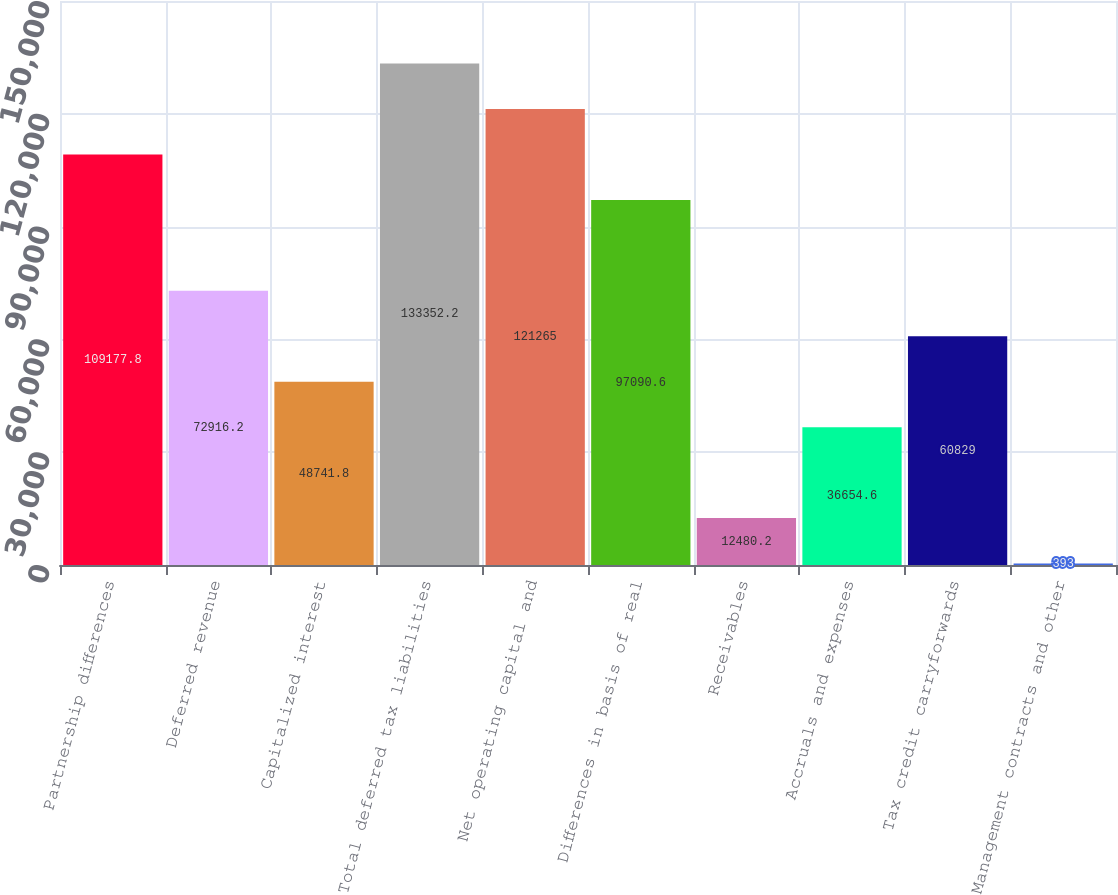<chart> <loc_0><loc_0><loc_500><loc_500><bar_chart><fcel>Partnership differences<fcel>Deferred revenue<fcel>Capitalized interest<fcel>Total deferred tax liabilities<fcel>Net operating capital and<fcel>Differences in basis of real<fcel>Receivables<fcel>Accruals and expenses<fcel>Tax credit carryforwards<fcel>Management contracts and other<nl><fcel>109178<fcel>72916.2<fcel>48741.8<fcel>133352<fcel>121265<fcel>97090.6<fcel>12480.2<fcel>36654.6<fcel>60829<fcel>393<nl></chart> 